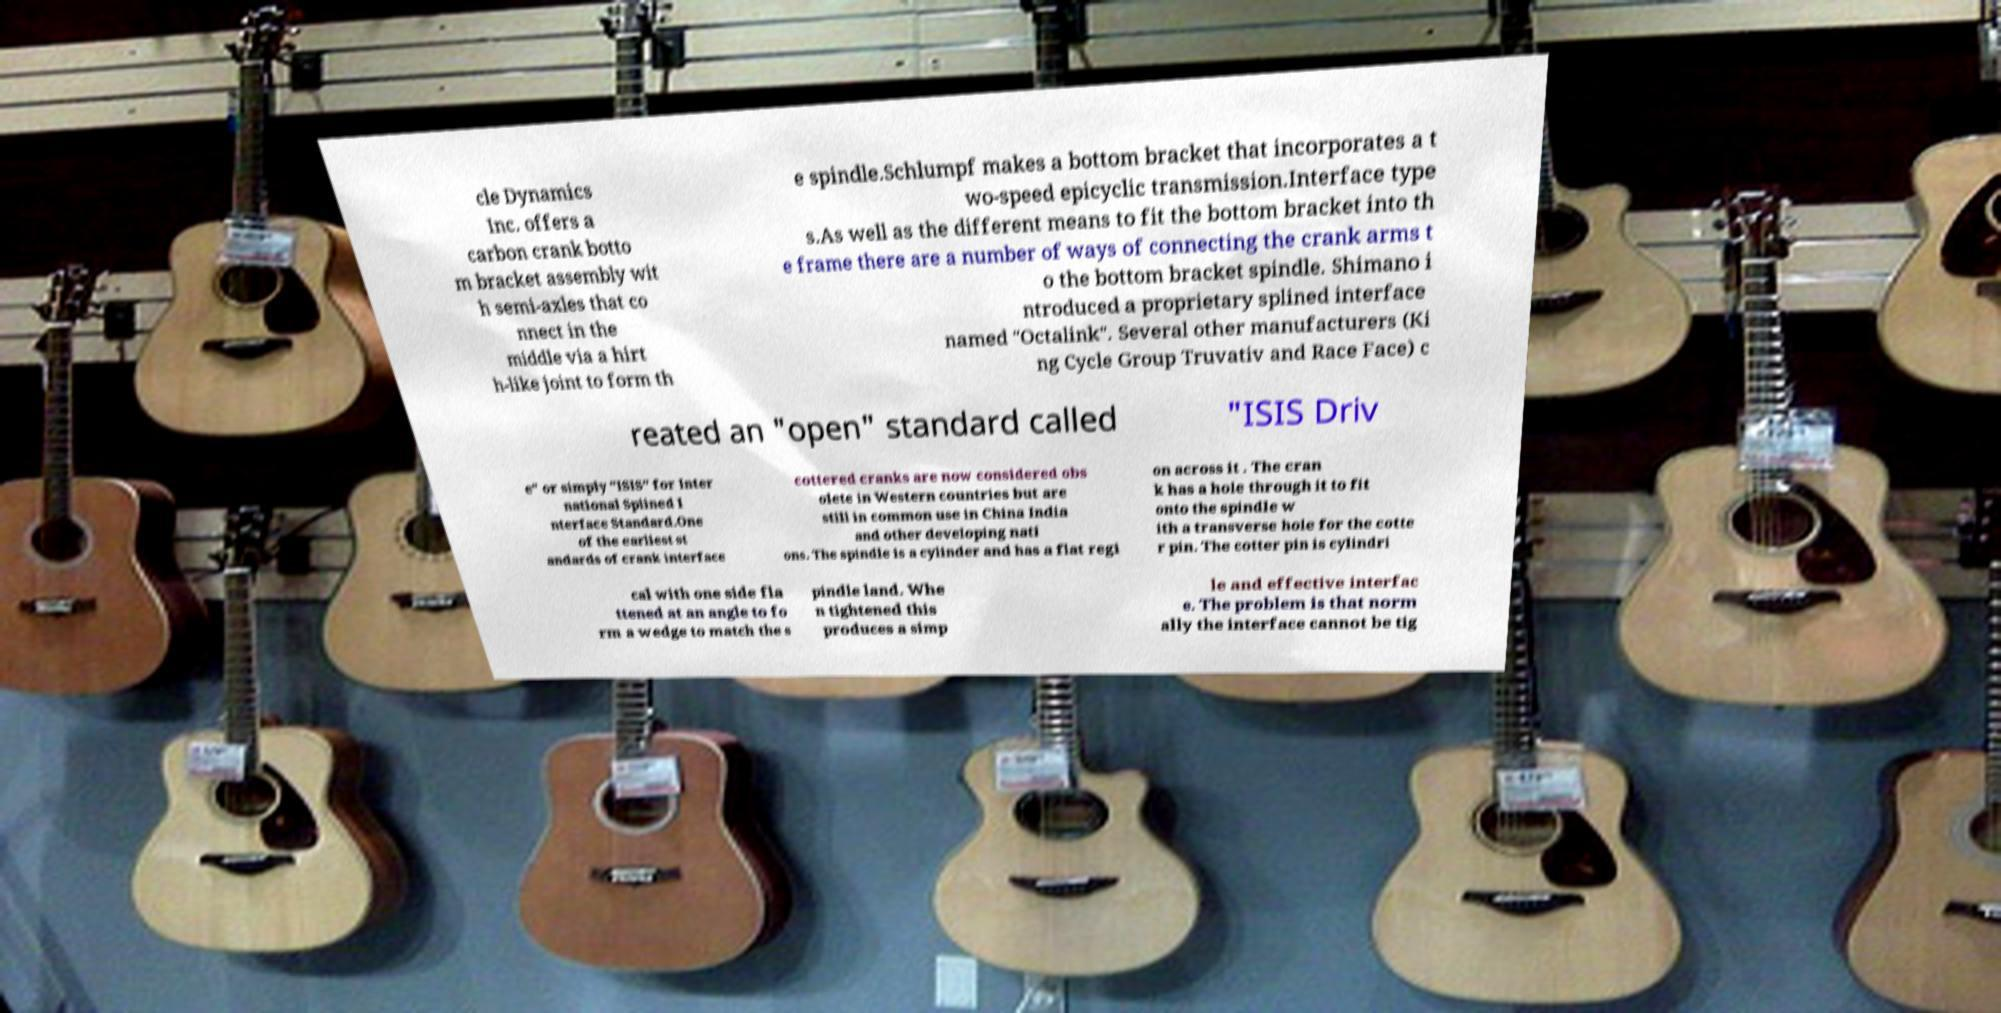Please read and relay the text visible in this image. What does it say? cle Dynamics Inc. offers a carbon crank botto m bracket assembly wit h semi-axles that co nnect in the middle via a hirt h-like joint to form th e spindle.Schlumpf makes a bottom bracket that incorporates a t wo-speed epicyclic transmission.Interface type s.As well as the different means to fit the bottom bracket into th e frame there are a number of ways of connecting the crank arms t o the bottom bracket spindle. Shimano i ntroduced a proprietary splined interface named "Octalink". Several other manufacturers (Ki ng Cycle Group Truvativ and Race Face) c reated an "open" standard called "ISIS Driv e" or simply "ISIS" for Inter national Splined I nterface Standard.One of the earliest st andards of crank interface cottered cranks are now considered obs olete in Western countries but are still in common use in China India and other developing nati ons. The spindle is a cylinder and has a flat regi on across it . The cran k has a hole through it to fit onto the spindle w ith a transverse hole for the cotte r pin. The cotter pin is cylindri cal with one side fla ttened at an angle to fo rm a wedge to match the s pindle land. Whe n tightened this produces a simp le and effective interfac e. The problem is that norm ally the interface cannot be tig 